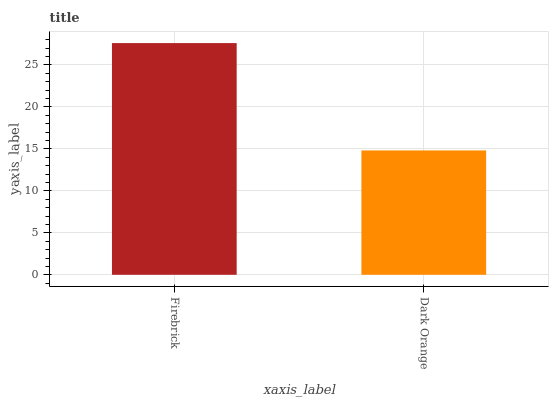Is Dark Orange the minimum?
Answer yes or no. Yes. Is Firebrick the maximum?
Answer yes or no. Yes. Is Dark Orange the maximum?
Answer yes or no. No. Is Firebrick greater than Dark Orange?
Answer yes or no. Yes. Is Dark Orange less than Firebrick?
Answer yes or no. Yes. Is Dark Orange greater than Firebrick?
Answer yes or no. No. Is Firebrick less than Dark Orange?
Answer yes or no. No. Is Firebrick the high median?
Answer yes or no. Yes. Is Dark Orange the low median?
Answer yes or no. Yes. Is Dark Orange the high median?
Answer yes or no. No. Is Firebrick the low median?
Answer yes or no. No. 